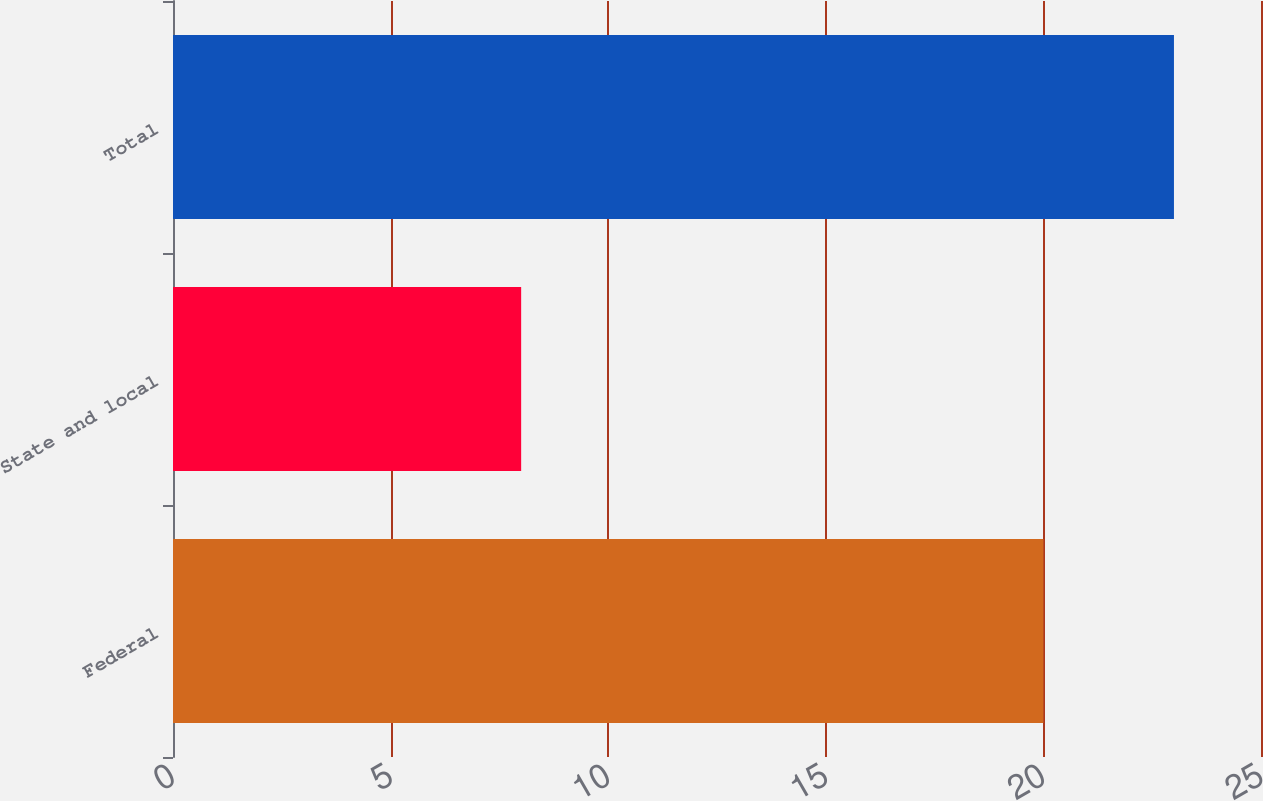Convert chart. <chart><loc_0><loc_0><loc_500><loc_500><bar_chart><fcel>Federal<fcel>State and local<fcel>Total<nl><fcel>20<fcel>8<fcel>23<nl></chart> 